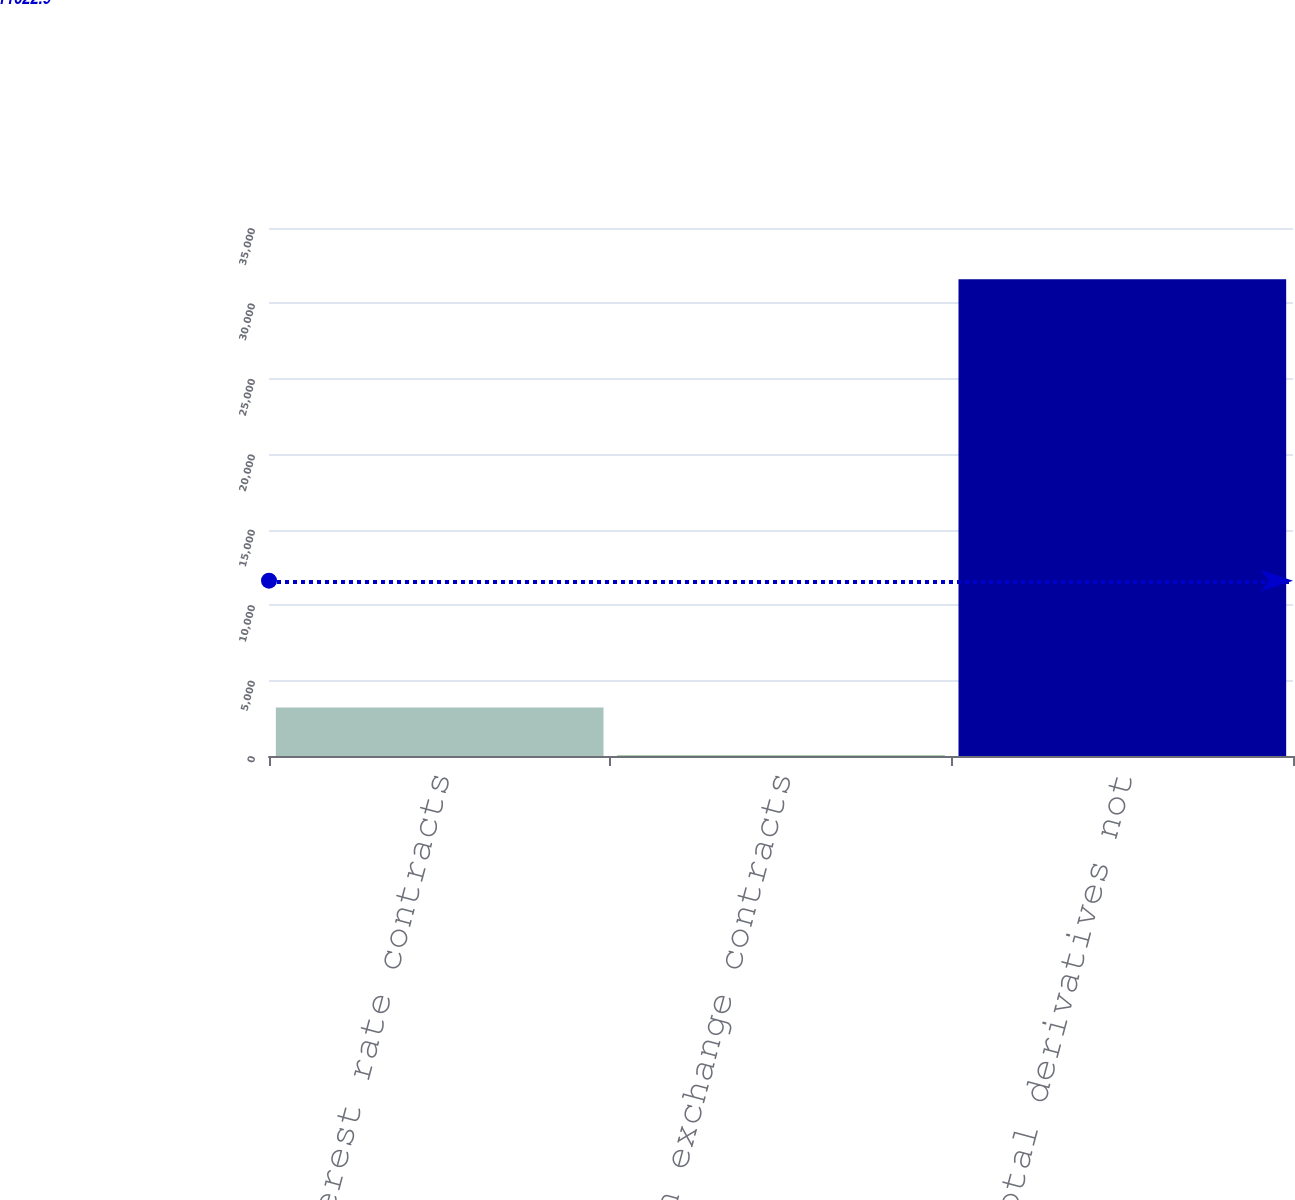<chart> <loc_0><loc_0><loc_500><loc_500><bar_chart><fcel>Interest rate contracts<fcel>Foreign exchange contracts<fcel>Total derivatives not<nl><fcel>3207.7<fcel>52<fcel>31609<nl></chart> 